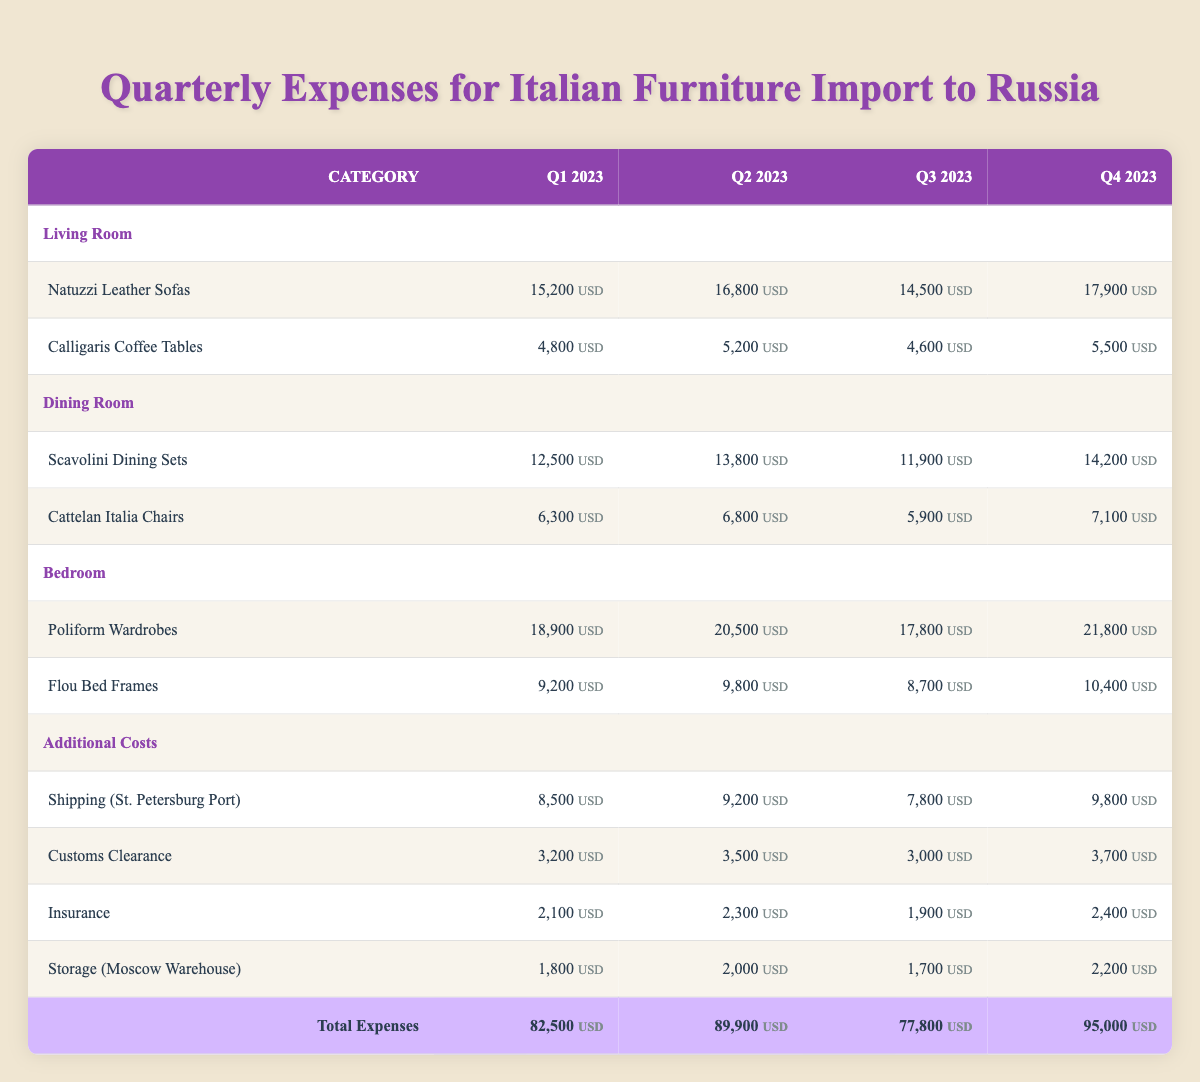What are the total expenses for Q4 2023? To find the total expenses for Q4 2023, I look at the "Total Expenses" row in the table. The value listed there for Q4 2023 is 95,000 USD.
Answer: 95,000 USD Which furniture category had the highest expenses in Q2 2023? I must compare the expenses for each category in Q2 2023. Living Room totals (16,800 + 5,200), Dining Room totals (13,800 + 6,800), and Bedroom totals (20,500 + 9,800). The Bedroom category has the highest total of 30,300 USD.
Answer: Bedroom What was the average expense for Shipping (St. Petersburg Port) across all quarters? I need to sum all the shipping expenses: 8,500 + 9,200 + 7,800 + 9,800 = 35,300. There are 4 quarters, so the average is 35,300 / 4 = 8,825 USD.
Answer: 8,825 USD Did the expenses for Calligaris Coffee Tables increase in Q3 2023 compared to Q2 2023? I look at the expenses for Calligaris Coffee Tables in both quarters: Q2 2023 is 5,200 USD and Q3 2023 is 4,600 USD. Since 4,600 is less than 5,200, the expenses decreased.
Answer: No What was the difference in total expenses between Q1 2023 and Q3 2023? First, I note the total expenses: Q1 2023 is 82,500 USD and Q3 2023 is 77,800 USD. To find the difference: 82,500 - 77,800 = 4,700 USD.
Answer: 4,700 USD Which item in the Bedroom category had the highest expense in Q4 2023? I check the expenses: Poliform Wardrobes is 21,800 USD and Flou Bed Frames is 10,400 USD for Q4 2023. The highest expense is thus for the Poliform Wardrobes.
Answer: Poliform Wardrobes What were the total expenses for the Dining Room category in Q1 2023? I check the expenses for the items within the Dining Room category for Q1 2023: Scavolini Dining Sets (12,500 USD) and Cattelan Italia Chairs (6,300 USD). Their sum is 12,500 + 6,300 = 18,800 USD.
Answer: 18,800 USD Was the insurance expense higher in Q2 2023 than in Q3 2023? I compare the insurance expenses: Q2 2023 is 2,300 USD, and Q3 2023 is 1,900 USD. Since 2,300 is greater than 1,900, the insurance expense was indeed higher in Q2 2023.
Answer: Yes 